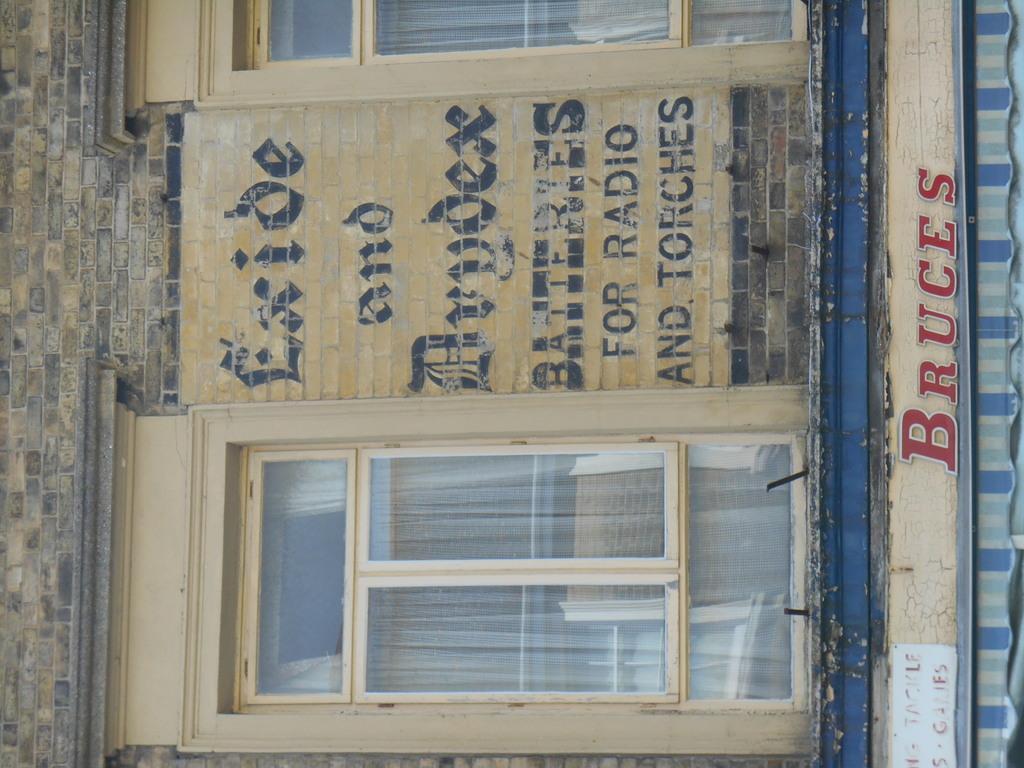Please provide a concise description of this image. In this image we can see a wall on which something is written. Here we can see the windows with glass and some text here and also the tent. 